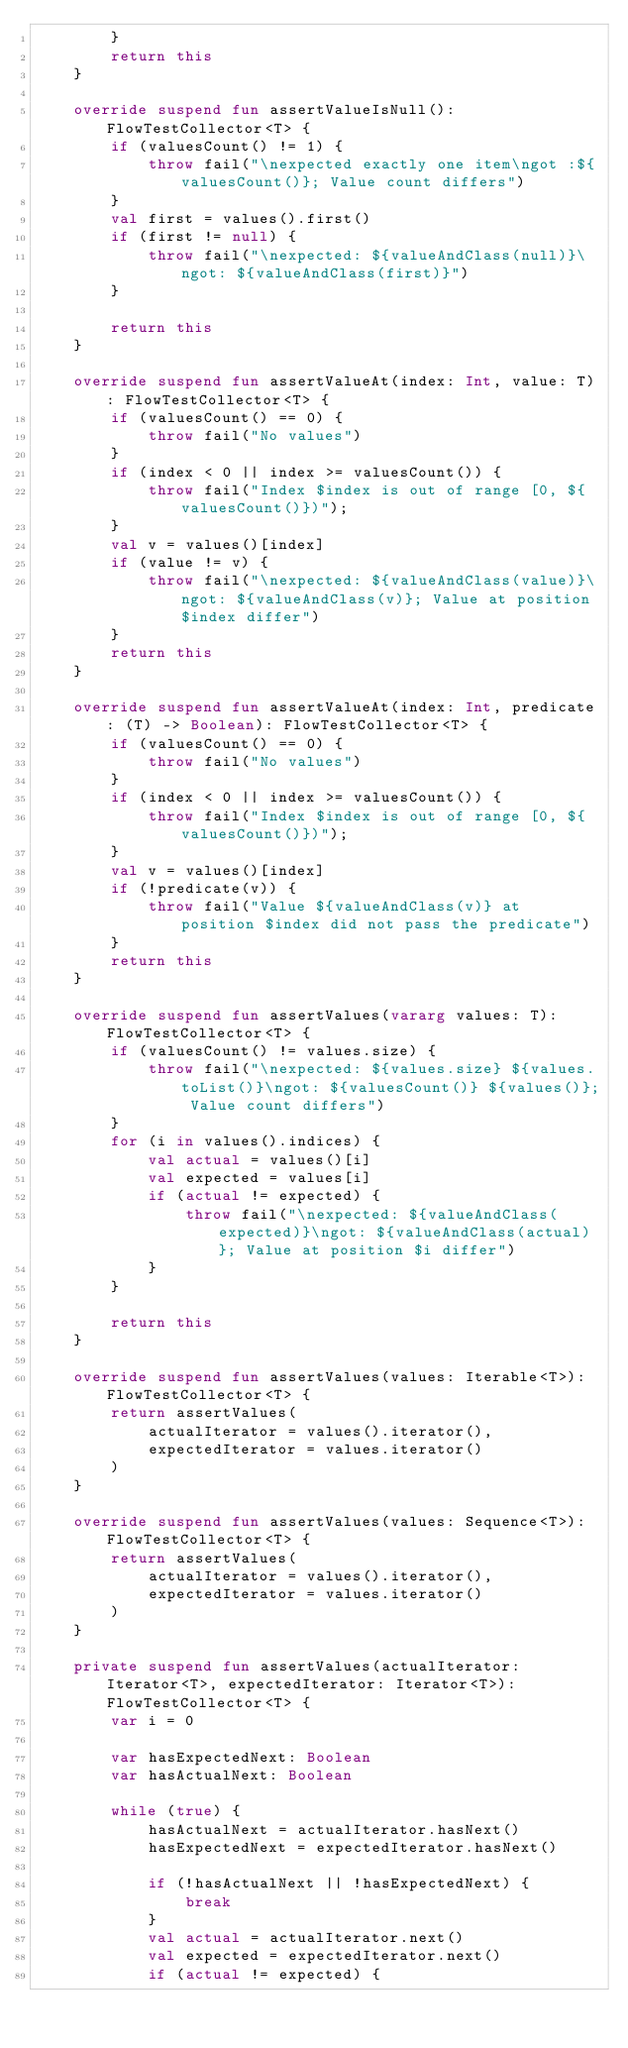<code> <loc_0><loc_0><loc_500><loc_500><_Kotlin_>        }
        return this
    }

    override suspend fun assertValueIsNull(): FlowTestCollector<T> {
        if (valuesCount() != 1) {
            throw fail("\nexpected exactly one item\ngot :${valuesCount()}; Value count differs")
        }
        val first = values().first()
        if (first != null) {
            throw fail("\nexpected: ${valueAndClass(null)}\ngot: ${valueAndClass(first)}")
        }

        return this
    }

    override suspend fun assertValueAt(index: Int, value: T): FlowTestCollector<T> {
        if (valuesCount() == 0) {
            throw fail("No values")
        }
        if (index < 0 || index >= valuesCount()) {
            throw fail("Index $index is out of range [0, ${valuesCount()})");
        }
        val v = values()[index]
        if (value != v) {
            throw fail("\nexpected: ${valueAndClass(value)}\ngot: ${valueAndClass(v)}; Value at position $index differ")
        }
        return this
    }

    override suspend fun assertValueAt(index: Int, predicate: (T) -> Boolean): FlowTestCollector<T> {
        if (valuesCount() == 0) {
            throw fail("No values")
        }
        if (index < 0 || index >= valuesCount()) {
            throw fail("Index $index is out of range [0, ${valuesCount()})");
        }
        val v = values()[index]
        if (!predicate(v)) {
            throw fail("Value ${valueAndClass(v)} at position $index did not pass the predicate")
        }
        return this
    }

    override suspend fun assertValues(vararg values: T): FlowTestCollector<T> {
        if (valuesCount() != values.size) {
            throw fail("\nexpected: ${values.size} ${values.toList()}\ngot: ${valuesCount()} ${values()}; Value count differs")
        }
        for (i in values().indices) {
            val actual = values()[i]
            val expected = values[i]
            if (actual != expected) {
                throw fail("\nexpected: ${valueAndClass(expected)}\ngot: ${valueAndClass(actual)}; Value at position $i differ")
            }
        }

        return this
    }

    override suspend fun assertValues(values: Iterable<T>): FlowTestCollector<T> {
        return assertValues(
            actualIterator = values().iterator(),
            expectedIterator = values.iterator()
        )
    }

    override suspend fun assertValues(values: Sequence<T>): FlowTestCollector<T> {
        return assertValues(
            actualIterator = values().iterator(),
            expectedIterator = values.iterator()
        )
    }

    private suspend fun assertValues(actualIterator: Iterator<T>, expectedIterator: Iterator<T>): FlowTestCollector<T> {
        var i = 0

        var hasExpectedNext: Boolean
        var hasActualNext: Boolean

        while (true) {
            hasActualNext = actualIterator.hasNext()
            hasExpectedNext = expectedIterator.hasNext()

            if (!hasActualNext || !hasExpectedNext) {
                break
            }
            val actual = actualIterator.next()
            val expected = expectedIterator.next()
            if (actual != expected) {</code> 